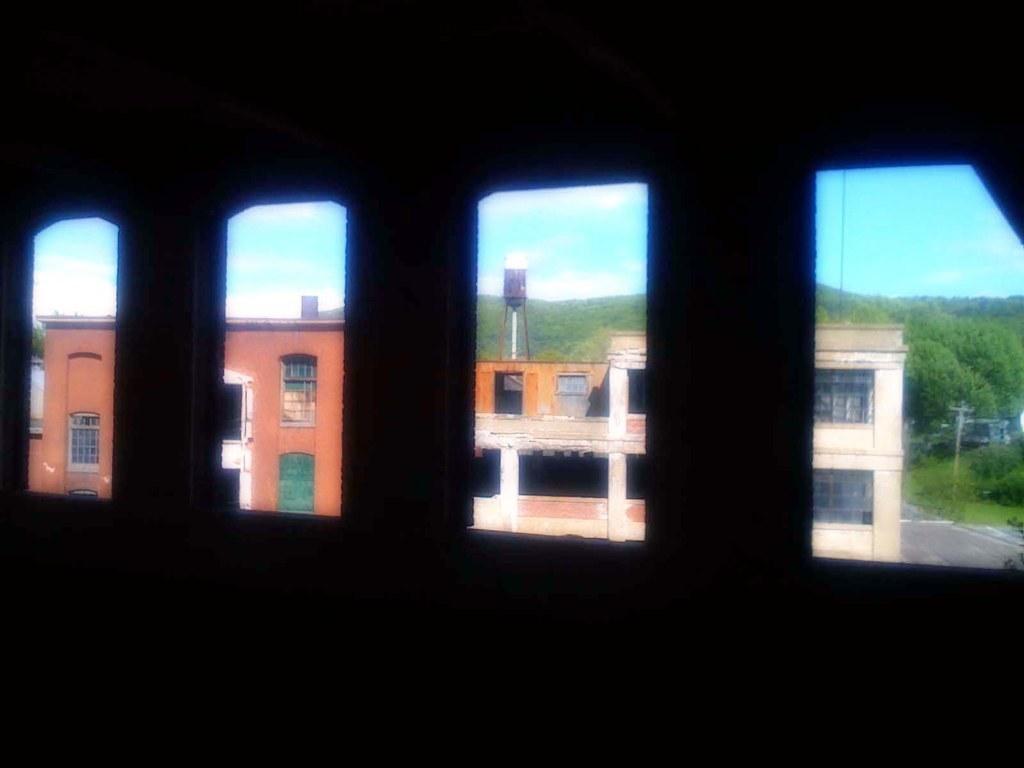Please provide a concise description of this image. There are windows on a building. Through the windows we can see buildings, trees and sky. 